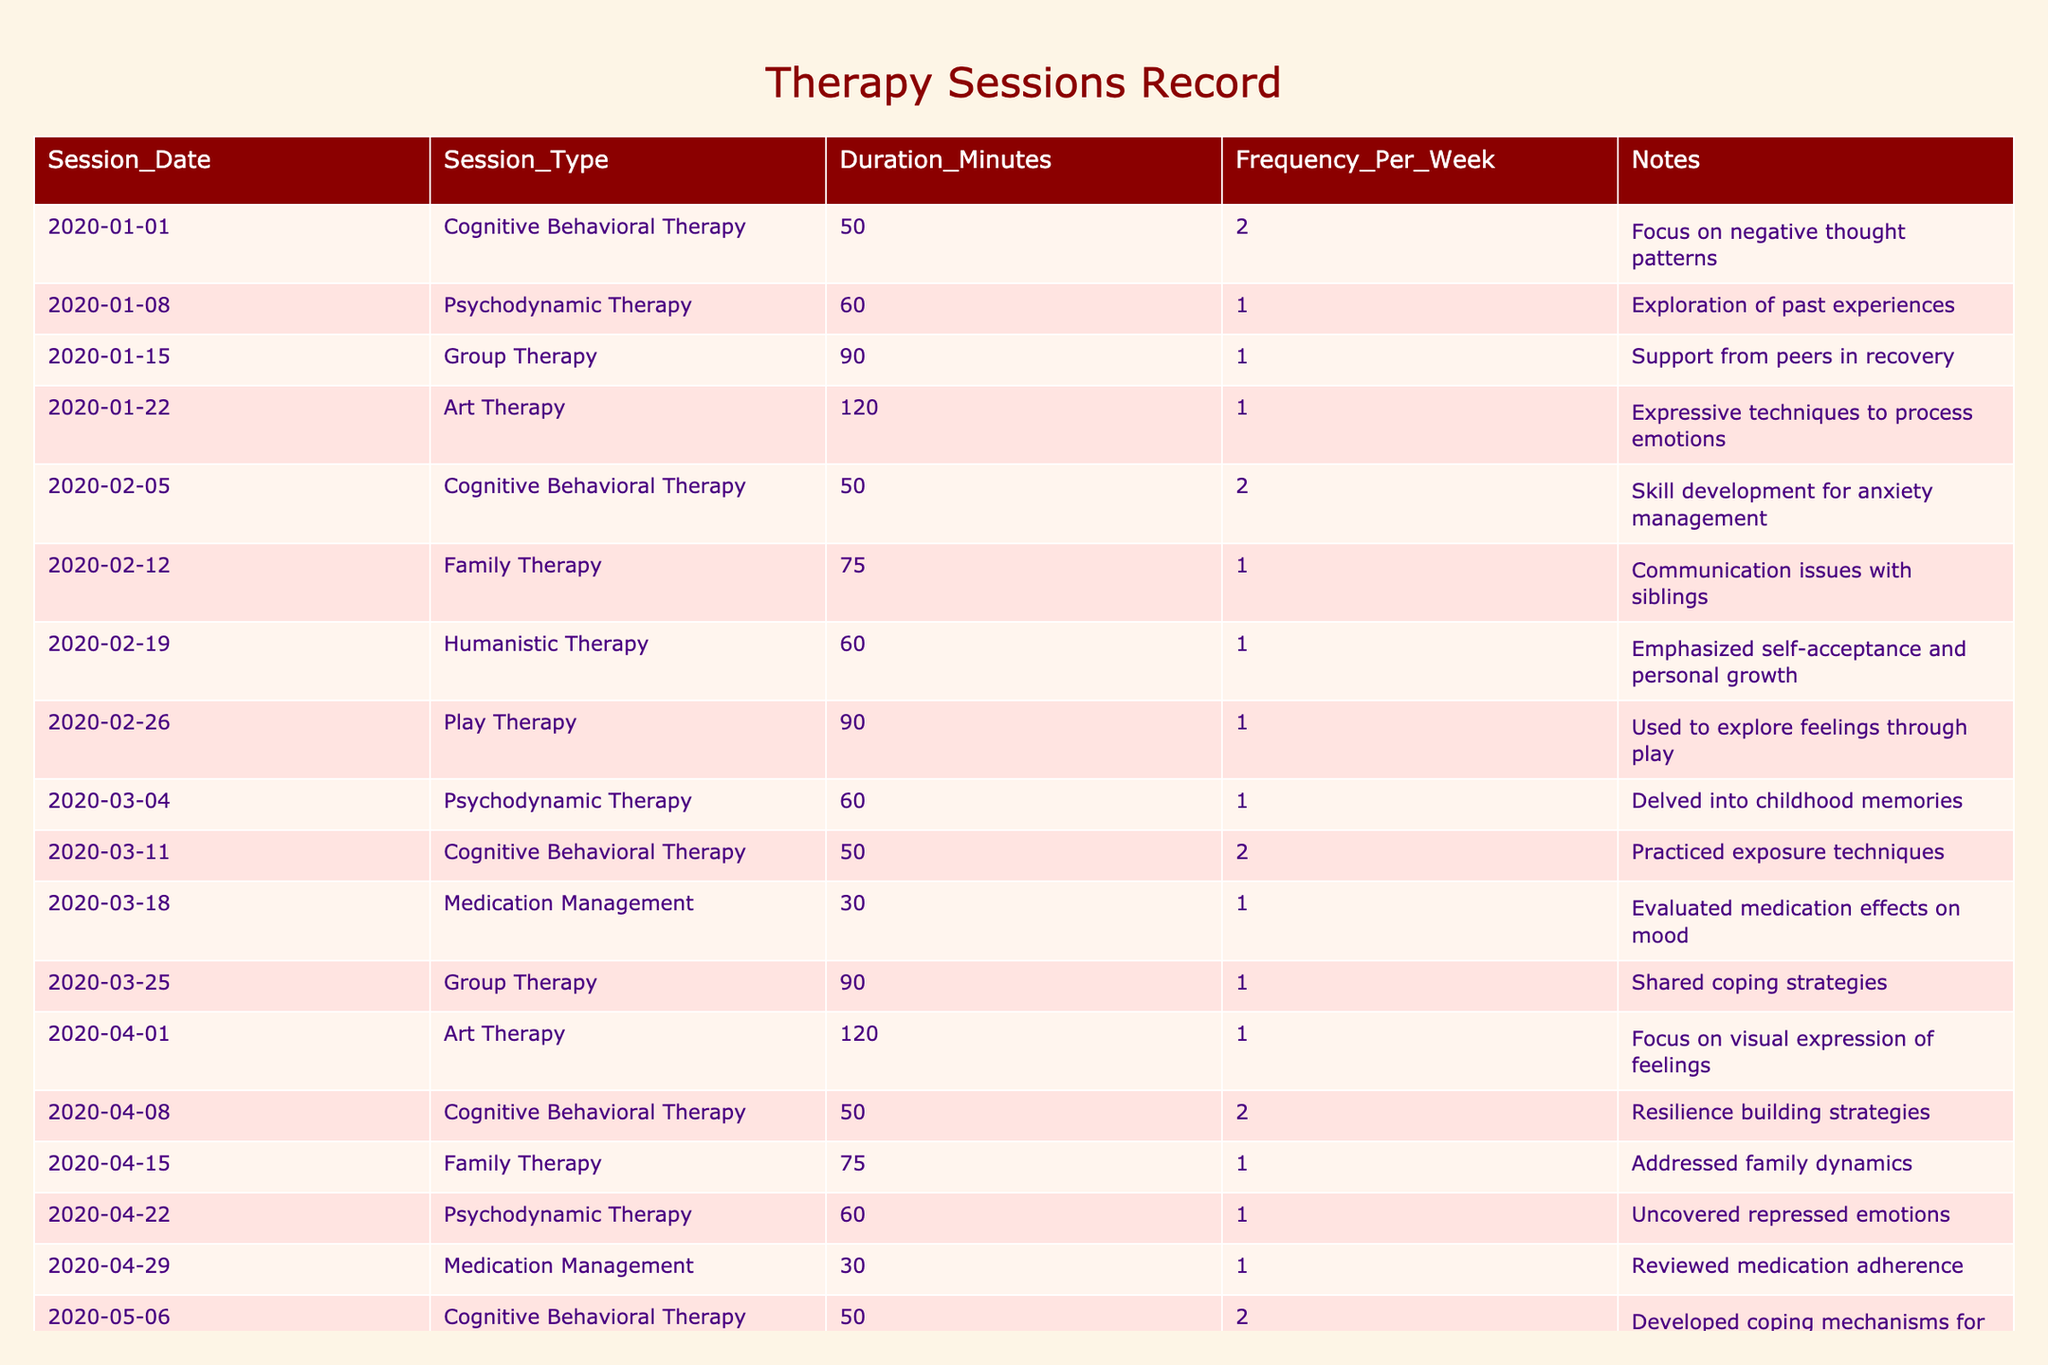What types of therapy sessions were attended during the treatment period? The table provides a list of different session types, including Cognitive Behavioral Therapy, Psychodynamic Therapy, Group Therapy, Art Therapy, Family Therapy, Humanistic Therapy, Play Therapy, Medication Management, and Psychoeducation.
Answer: Multiple types How many sessions of Cognitive Behavioral Therapy were conducted? The table lists Cognitive Behavioral Therapy sessions on 2020-01-01, 2020-02-05, 2020-03-11, 2020-04-08, and 2020-05-06. There are a total of five sessions.
Answer: 5 What was the longest therapy session type by duration? The table shows that Art Therapy sessions lasted 120 minutes, which is longer than all other session types listed.
Answer: Art Therapy What was the total frequency of sessions attended per week by session type? First, count the frequency per each session type: Cognitive Behavioral Therapy (2), Psychodynamic Therapy (1), Group Therapy (1), Art Therapy (1), Family Therapy (1), Humanistic Therapy (1), Play Therapy (1), Medication Management (1), Psychoeducation (1). The total frequency across all types is 2 + 1 + 1 + 1 + 1 + 1 + 1 + 1 + 1 = 11.
Answer: 11 On which date was the last therapy session held, and what type was it? The last date in the session records is 2020-05-27, which is when the last Art Therapy session took place.
Answer: 2020-05-27, Art Therapy How many different therapy types were utilized throughout the treatment? The unique session types listed in the table are nine: Cognitive Behavioral Therapy, Psychodynamic Therapy, Group Therapy, Art Therapy, Family Therapy, Humanistic Therapy, Play Therapy, Medication Management, and Psychoeducation. Counting these gives a total of nine different therapy types.
Answer: 9 What percentage of the therapy sessions were Cognitive Behavioral Therapy? There are 21 total sessions in the table, and 5 of them were Cognitive Behavioral Therapy. Therefore, the percentage of Cognitive Behavioral Therapy sessions is (5 / 21) * 100 = approximately 23.81%.
Answer: 23.81% Was there ever a week with more than two therapy sessions? Analyzing the frequency values, there are two sessions per week only for Cognitive Behavioral Therapy, but no other session types exceed this frequency. Therefore, the answer is no, there were never more than two sessions in a week.
Answer: No Which therapy session type had the most significant emphasis on personal growth? The Humanistic Therapy session explicitly emphasized self-acceptance and personal growth. This indicates a focus on these areas compared to other therapies.
Answer: Humanistic Therapy How does the duration of Group Therapy compare to the average duration of all therapy sessions? The Group Therapy sessions have a duration of 90 minutes each. To find the average, sum all durations (50 + 60 + 90 + 120 + 50 + 75 + 60 + 90 + 60 + 30 + 90 + 120 + 50 + 75 + 60 + 30 + 50 + 90 + 60 + 120) and divide by the number of sessions (21). This gives an average duration of approximately 66.43 minutes. Thus, 90 minutes is above average.
Answer: Above average 